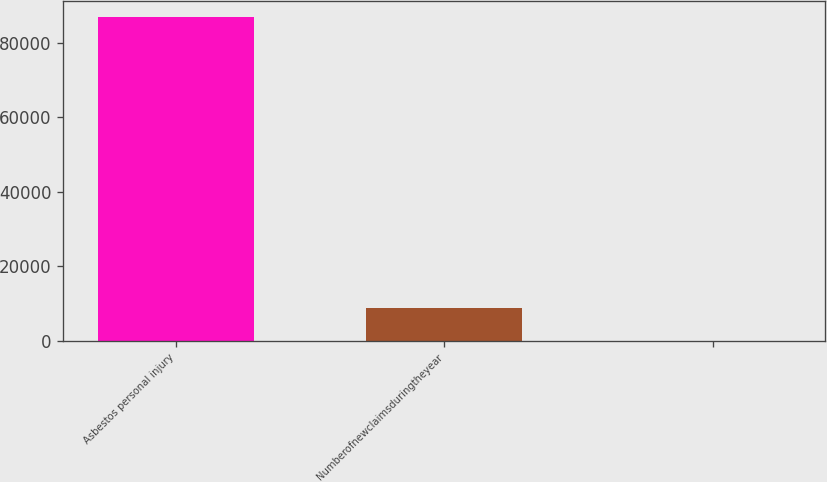Convert chart to OTSL. <chart><loc_0><loc_0><loc_500><loc_500><bar_chart><fcel>Asbestos personal injury<fcel>Numberofnewclaimsduringtheyear<fcel>Unnamed: 2<nl><fcel>87070<fcel>8738.95<fcel>35.5<nl></chart> 